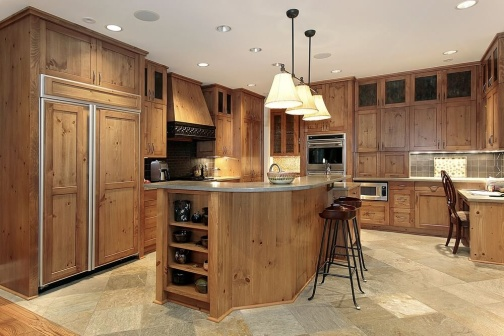What is this photo about'?
 The image captures a warm and inviting kitchen space. Dominating the scene are wooden cabinets with a natural finish, their earthy tones lending a rustic charm to the room. The cabinets are complemented by stainless steel appliances that add a modern touch. 

A center island serves as the heart of the kitchen, equipped with a sink and a wine rack. It's a functional and social hub, with three bar stools tucked under it, inviting conversation while meals are being prepared. 

The floor is covered in tiles, providing a practical yet stylish base for the room. Above, a chandelier hangs from the ceiling, ready to cast a soft glow when the day turns to night. 

A window is situated above the sink, offering a view to the outside world while washing dishes or preparing food. The precise location of objects and their relative positions contribute to a well-organized and efficient layout. 

Despite the absence of people, the image conveys a sense of life and activity. It's easy to imagine the clatter of pots and pans, the aroma of cooking food, and the sound of laughter filling this space. This kitchen, with its blend of rustic charm and modern amenities, is truly the heart of a home. 